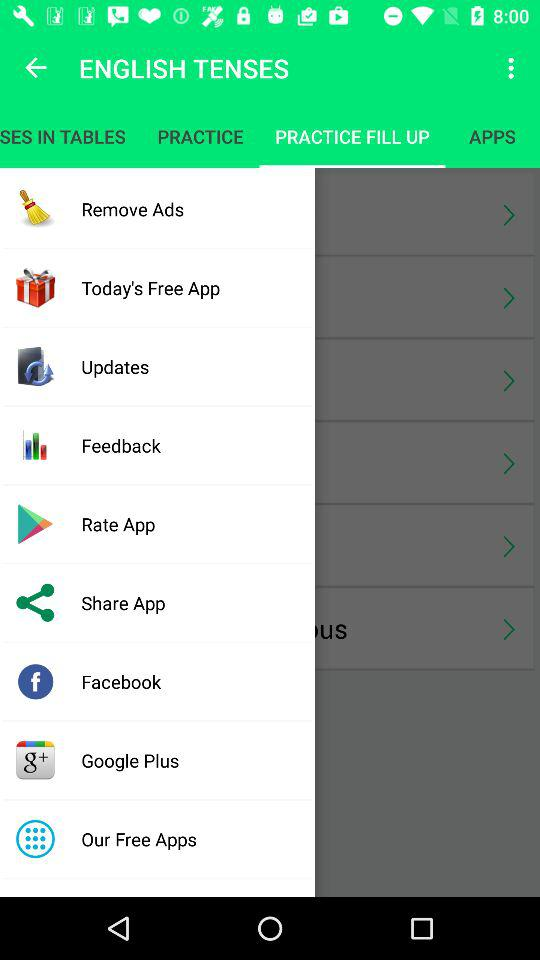What is the application name? The application name is "ENGLISH TENSES". 